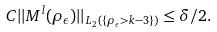<formula> <loc_0><loc_0><loc_500><loc_500>C | | M ^ { l } ( \rho _ { \epsilon } ) | | _ { L _ { 2 } ( \{ \rho _ { \epsilon } > k - 3 \} ) } \leq \delta / 2 .</formula> 